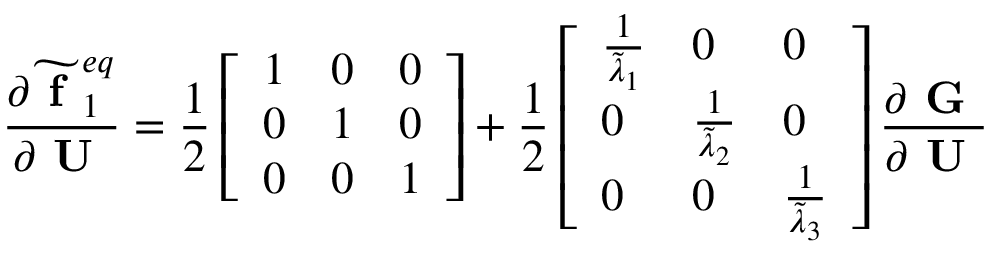Convert formula to latex. <formula><loc_0><loc_0><loc_500><loc_500>\frac { \partial \widetilde { f } _ { 1 } ^ { e q } } { \partial U } = \frac { 1 } { 2 } \left [ \begin{array} { l l l } { 1 } & { 0 } & { 0 } \\ { 0 } & { 1 } & { 0 } \\ { 0 } & { 0 } & { 1 } \end{array} \right ] + \frac { 1 } { 2 } \left [ \begin{array} { l l l } { \frac { 1 } { \widetilde { \lambda } _ { 1 } } } & { 0 } & { 0 } \\ { 0 } & { \frac { 1 } { \widetilde { \lambda } _ { 2 } } } & { 0 } \\ { 0 } & { 0 } & { \frac { 1 } { \widetilde { \lambda } _ { 3 } } } \end{array} \right ] \frac { \partial G } { \partial U }</formula> 